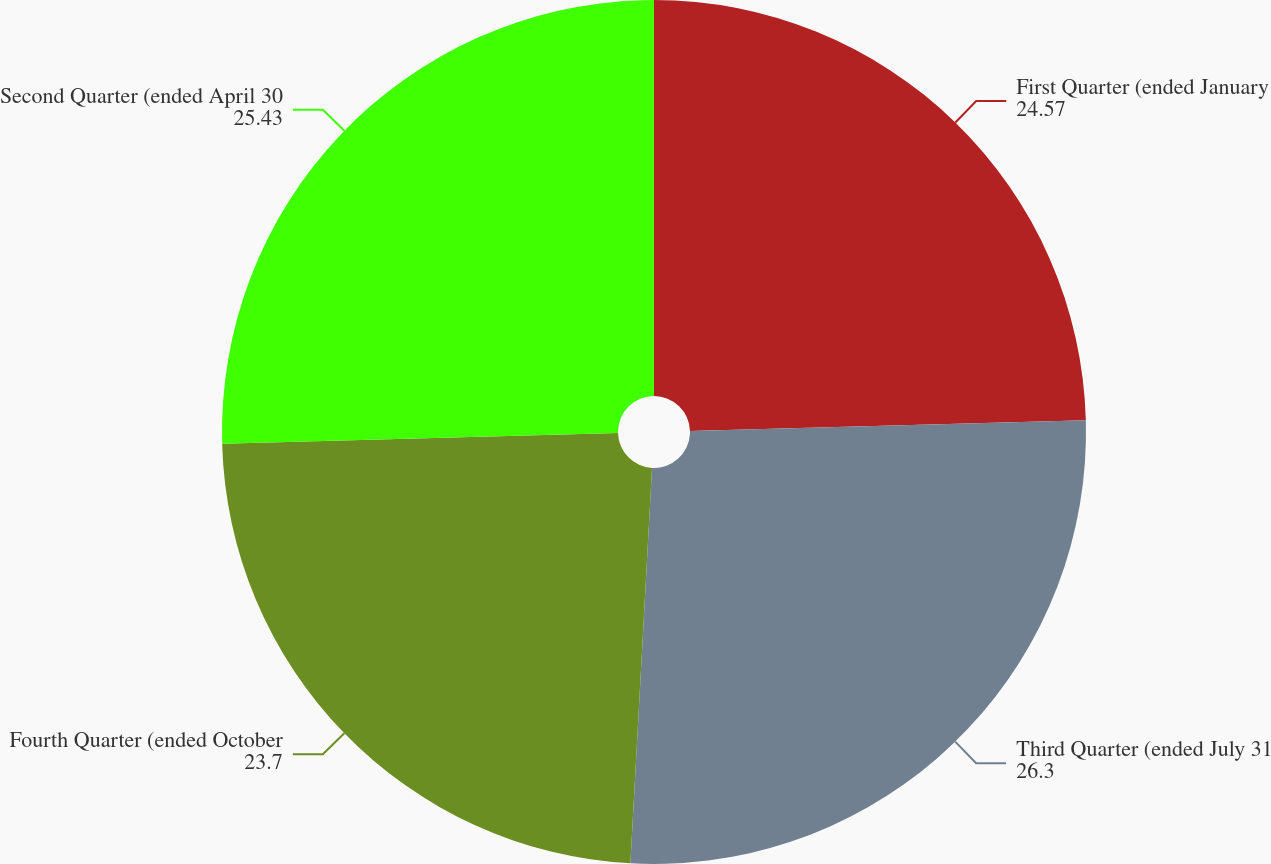<chart> <loc_0><loc_0><loc_500><loc_500><pie_chart><fcel>First Quarter (ended January<fcel>Third Quarter (ended July 31<fcel>Fourth Quarter (ended October<fcel>Second Quarter (ended April 30<nl><fcel>24.57%<fcel>26.3%<fcel>23.7%<fcel>25.43%<nl></chart> 